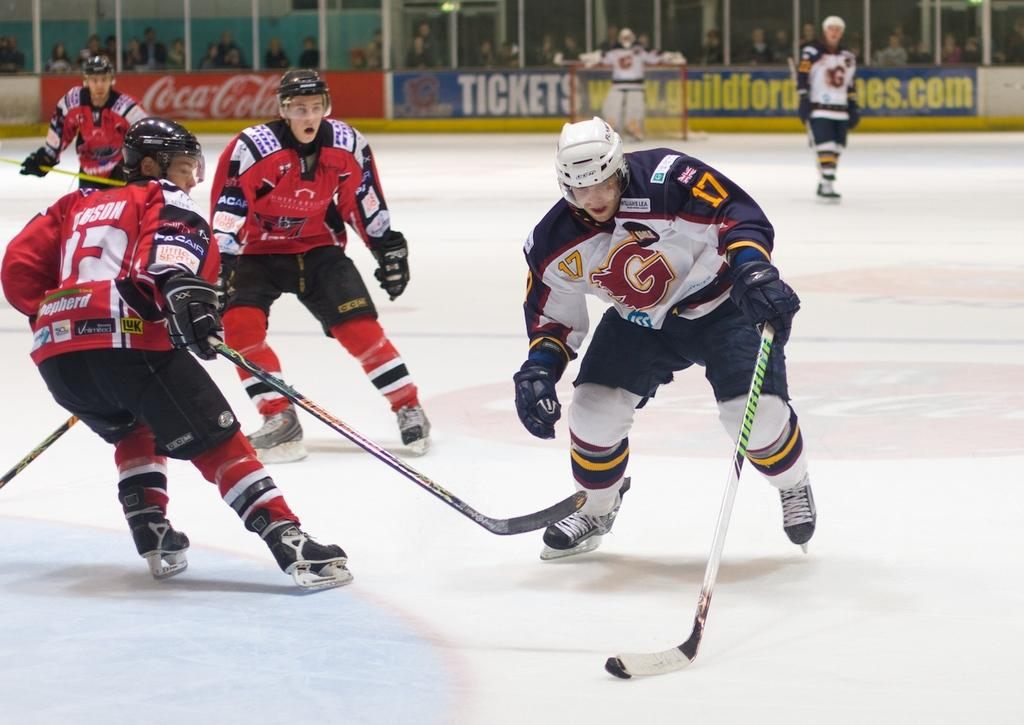What type of protective gear are the people wearing in the image? The people are wearing helmets in the image. What other clothing items can be seen on the people in the image? The people are wearing gloves and ice skating shoes in the image. What equipment are the people holding in the image? The people are holding hockey sticks in the image. What sport are the people playing in the image? The people are playing ice hockey in the image. What can be seen in the background of the image? There are banners and many people in the background of the image. What type of stew is being served to the dolls in the image? There are no dolls or stew present in the image; it features people playing ice hockey. What type of soap is being used to clean the ice skating shoes in the image? There is no soap or cleaning activity depicted in the image; it simply shows people playing ice hockey. 